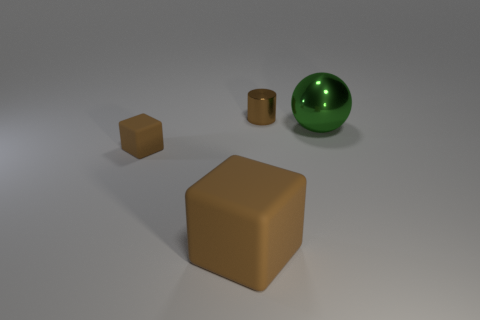Add 3 small brown matte blocks. How many objects exist? 7 Subtract all spheres. How many objects are left? 3 Subtract 1 spheres. How many spheres are left? 0 Subtract all red balls. Subtract all large brown rubber objects. How many objects are left? 3 Add 3 metallic objects. How many metallic objects are left? 5 Add 4 small cylinders. How many small cylinders exist? 5 Subtract 0 green blocks. How many objects are left? 4 Subtract all purple cylinders. Subtract all yellow cubes. How many cylinders are left? 1 